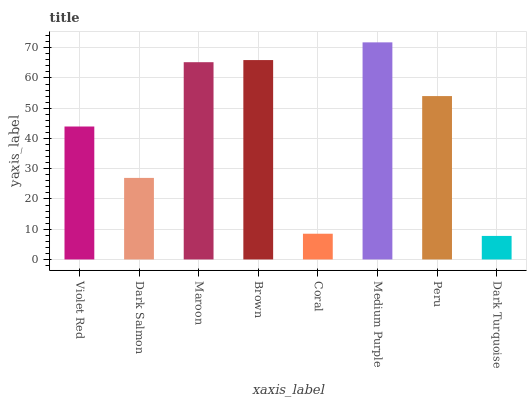Is Dark Turquoise the minimum?
Answer yes or no. Yes. Is Medium Purple the maximum?
Answer yes or no. Yes. Is Dark Salmon the minimum?
Answer yes or no. No. Is Dark Salmon the maximum?
Answer yes or no. No. Is Violet Red greater than Dark Salmon?
Answer yes or no. Yes. Is Dark Salmon less than Violet Red?
Answer yes or no. Yes. Is Dark Salmon greater than Violet Red?
Answer yes or no. No. Is Violet Red less than Dark Salmon?
Answer yes or no. No. Is Peru the high median?
Answer yes or no. Yes. Is Violet Red the low median?
Answer yes or no. Yes. Is Dark Turquoise the high median?
Answer yes or no. No. Is Medium Purple the low median?
Answer yes or no. No. 